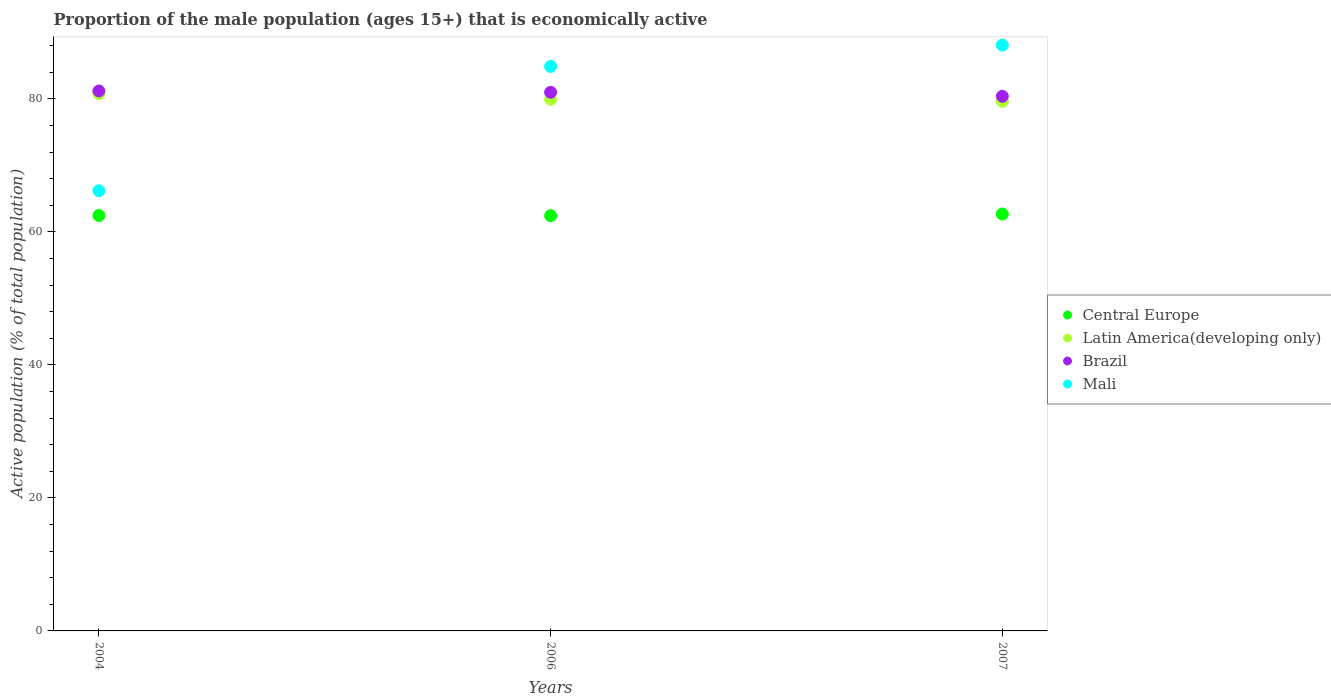What is the proportion of the male population that is economically active in Brazil in 2004?
Provide a short and direct response. 81.2. Across all years, what is the maximum proportion of the male population that is economically active in Latin America(developing only)?
Ensure brevity in your answer.  80.81. Across all years, what is the minimum proportion of the male population that is economically active in Brazil?
Give a very brief answer. 80.4. In which year was the proportion of the male population that is economically active in Mali maximum?
Offer a very short reply. 2007. What is the total proportion of the male population that is economically active in Mali in the graph?
Your answer should be compact. 239.2. What is the difference between the proportion of the male population that is economically active in Central Europe in 2004 and that in 2007?
Offer a terse response. -0.23. What is the difference between the proportion of the male population that is economically active in Brazil in 2006 and the proportion of the male population that is economically active in Central Europe in 2007?
Provide a succinct answer. 18.3. What is the average proportion of the male population that is economically active in Mali per year?
Offer a terse response. 79.73. In the year 2004, what is the difference between the proportion of the male population that is economically active in Latin America(developing only) and proportion of the male population that is economically active in Brazil?
Your answer should be very brief. -0.39. What is the ratio of the proportion of the male population that is economically active in Latin America(developing only) in 2004 to that in 2006?
Offer a terse response. 1.01. What is the difference between the highest and the second highest proportion of the male population that is economically active in Central Europe?
Keep it short and to the point. 0.23. What is the difference between the highest and the lowest proportion of the male population that is economically active in Mali?
Offer a very short reply. 21.9. Is the sum of the proportion of the male population that is economically active in Brazil in 2004 and 2006 greater than the maximum proportion of the male population that is economically active in Mali across all years?
Offer a terse response. Yes. Is it the case that in every year, the sum of the proportion of the male population that is economically active in Brazil and proportion of the male population that is economically active in Latin America(developing only)  is greater than the sum of proportion of the male population that is economically active in Mali and proportion of the male population that is economically active in Central Europe?
Provide a short and direct response. No. How many dotlines are there?
Make the answer very short. 4. How many years are there in the graph?
Your answer should be very brief. 3. What is the difference between two consecutive major ticks on the Y-axis?
Make the answer very short. 20. Are the values on the major ticks of Y-axis written in scientific E-notation?
Your answer should be very brief. No. Where does the legend appear in the graph?
Provide a short and direct response. Center right. What is the title of the graph?
Provide a short and direct response. Proportion of the male population (ages 15+) that is economically active. Does "Cayman Islands" appear as one of the legend labels in the graph?
Offer a terse response. No. What is the label or title of the Y-axis?
Your response must be concise. Active population (% of total population). What is the Active population (% of total population) of Central Europe in 2004?
Keep it short and to the point. 62.47. What is the Active population (% of total population) of Latin America(developing only) in 2004?
Provide a short and direct response. 80.81. What is the Active population (% of total population) of Brazil in 2004?
Your response must be concise. 81.2. What is the Active population (% of total population) in Mali in 2004?
Give a very brief answer. 66.2. What is the Active population (% of total population) of Central Europe in 2006?
Your response must be concise. 62.45. What is the Active population (% of total population) in Latin America(developing only) in 2006?
Give a very brief answer. 79.95. What is the Active population (% of total population) of Brazil in 2006?
Keep it short and to the point. 81. What is the Active population (% of total population) of Mali in 2006?
Offer a very short reply. 84.9. What is the Active population (% of total population) of Central Europe in 2007?
Keep it short and to the point. 62.7. What is the Active population (% of total population) of Latin America(developing only) in 2007?
Your answer should be compact. 79.64. What is the Active population (% of total population) of Brazil in 2007?
Ensure brevity in your answer.  80.4. What is the Active population (% of total population) of Mali in 2007?
Offer a very short reply. 88.1. Across all years, what is the maximum Active population (% of total population) of Central Europe?
Ensure brevity in your answer.  62.7. Across all years, what is the maximum Active population (% of total population) in Latin America(developing only)?
Your answer should be very brief. 80.81. Across all years, what is the maximum Active population (% of total population) in Brazil?
Make the answer very short. 81.2. Across all years, what is the maximum Active population (% of total population) of Mali?
Offer a very short reply. 88.1. Across all years, what is the minimum Active population (% of total population) in Central Europe?
Offer a very short reply. 62.45. Across all years, what is the minimum Active population (% of total population) of Latin America(developing only)?
Make the answer very short. 79.64. Across all years, what is the minimum Active population (% of total population) in Brazil?
Your answer should be very brief. 80.4. Across all years, what is the minimum Active population (% of total population) of Mali?
Offer a very short reply. 66.2. What is the total Active population (% of total population) in Central Europe in the graph?
Offer a very short reply. 187.62. What is the total Active population (% of total population) of Latin America(developing only) in the graph?
Give a very brief answer. 240.39. What is the total Active population (% of total population) in Brazil in the graph?
Offer a terse response. 242.6. What is the total Active population (% of total population) of Mali in the graph?
Keep it short and to the point. 239.2. What is the difference between the Active population (% of total population) of Central Europe in 2004 and that in 2006?
Ensure brevity in your answer.  0.03. What is the difference between the Active population (% of total population) of Latin America(developing only) in 2004 and that in 2006?
Your answer should be compact. 0.86. What is the difference between the Active population (% of total population) of Brazil in 2004 and that in 2006?
Ensure brevity in your answer.  0.2. What is the difference between the Active population (% of total population) in Mali in 2004 and that in 2006?
Make the answer very short. -18.7. What is the difference between the Active population (% of total population) in Central Europe in 2004 and that in 2007?
Provide a short and direct response. -0.23. What is the difference between the Active population (% of total population) of Latin America(developing only) in 2004 and that in 2007?
Your response must be concise. 1.17. What is the difference between the Active population (% of total population) of Brazil in 2004 and that in 2007?
Offer a terse response. 0.8. What is the difference between the Active population (% of total population) of Mali in 2004 and that in 2007?
Offer a terse response. -21.9. What is the difference between the Active population (% of total population) in Central Europe in 2006 and that in 2007?
Your answer should be compact. -0.25. What is the difference between the Active population (% of total population) in Latin America(developing only) in 2006 and that in 2007?
Keep it short and to the point. 0.31. What is the difference between the Active population (% of total population) in Brazil in 2006 and that in 2007?
Your answer should be compact. 0.6. What is the difference between the Active population (% of total population) in Central Europe in 2004 and the Active population (% of total population) in Latin America(developing only) in 2006?
Your answer should be very brief. -17.48. What is the difference between the Active population (% of total population) in Central Europe in 2004 and the Active population (% of total population) in Brazil in 2006?
Your answer should be very brief. -18.53. What is the difference between the Active population (% of total population) of Central Europe in 2004 and the Active population (% of total population) of Mali in 2006?
Make the answer very short. -22.43. What is the difference between the Active population (% of total population) of Latin America(developing only) in 2004 and the Active population (% of total population) of Brazil in 2006?
Your answer should be compact. -0.19. What is the difference between the Active population (% of total population) in Latin America(developing only) in 2004 and the Active population (% of total population) in Mali in 2006?
Offer a terse response. -4.09. What is the difference between the Active population (% of total population) of Central Europe in 2004 and the Active population (% of total population) of Latin America(developing only) in 2007?
Offer a terse response. -17.17. What is the difference between the Active population (% of total population) in Central Europe in 2004 and the Active population (% of total population) in Brazil in 2007?
Your answer should be compact. -17.93. What is the difference between the Active population (% of total population) of Central Europe in 2004 and the Active population (% of total population) of Mali in 2007?
Make the answer very short. -25.63. What is the difference between the Active population (% of total population) of Latin America(developing only) in 2004 and the Active population (% of total population) of Brazil in 2007?
Keep it short and to the point. 0.41. What is the difference between the Active population (% of total population) of Latin America(developing only) in 2004 and the Active population (% of total population) of Mali in 2007?
Provide a succinct answer. -7.29. What is the difference between the Active population (% of total population) in Brazil in 2004 and the Active population (% of total population) in Mali in 2007?
Make the answer very short. -6.9. What is the difference between the Active population (% of total population) in Central Europe in 2006 and the Active population (% of total population) in Latin America(developing only) in 2007?
Keep it short and to the point. -17.19. What is the difference between the Active population (% of total population) in Central Europe in 2006 and the Active population (% of total population) in Brazil in 2007?
Your answer should be very brief. -17.95. What is the difference between the Active population (% of total population) in Central Europe in 2006 and the Active population (% of total population) in Mali in 2007?
Your answer should be very brief. -25.65. What is the difference between the Active population (% of total population) of Latin America(developing only) in 2006 and the Active population (% of total population) of Brazil in 2007?
Your response must be concise. -0.45. What is the difference between the Active population (% of total population) of Latin America(developing only) in 2006 and the Active population (% of total population) of Mali in 2007?
Provide a succinct answer. -8.15. What is the difference between the Active population (% of total population) of Brazil in 2006 and the Active population (% of total population) of Mali in 2007?
Provide a short and direct response. -7.1. What is the average Active population (% of total population) in Central Europe per year?
Keep it short and to the point. 62.54. What is the average Active population (% of total population) of Latin America(developing only) per year?
Offer a terse response. 80.13. What is the average Active population (% of total population) in Brazil per year?
Offer a terse response. 80.87. What is the average Active population (% of total population) of Mali per year?
Offer a terse response. 79.73. In the year 2004, what is the difference between the Active population (% of total population) of Central Europe and Active population (% of total population) of Latin America(developing only)?
Ensure brevity in your answer.  -18.33. In the year 2004, what is the difference between the Active population (% of total population) of Central Europe and Active population (% of total population) of Brazil?
Offer a very short reply. -18.73. In the year 2004, what is the difference between the Active population (% of total population) of Central Europe and Active population (% of total population) of Mali?
Give a very brief answer. -3.73. In the year 2004, what is the difference between the Active population (% of total population) in Latin America(developing only) and Active population (% of total population) in Brazil?
Make the answer very short. -0.39. In the year 2004, what is the difference between the Active population (% of total population) in Latin America(developing only) and Active population (% of total population) in Mali?
Provide a succinct answer. 14.61. In the year 2006, what is the difference between the Active population (% of total population) of Central Europe and Active population (% of total population) of Latin America(developing only)?
Provide a short and direct response. -17.5. In the year 2006, what is the difference between the Active population (% of total population) in Central Europe and Active population (% of total population) in Brazil?
Your answer should be very brief. -18.55. In the year 2006, what is the difference between the Active population (% of total population) in Central Europe and Active population (% of total population) in Mali?
Provide a short and direct response. -22.45. In the year 2006, what is the difference between the Active population (% of total population) of Latin America(developing only) and Active population (% of total population) of Brazil?
Offer a terse response. -1.05. In the year 2006, what is the difference between the Active population (% of total population) of Latin America(developing only) and Active population (% of total population) of Mali?
Make the answer very short. -4.95. In the year 2007, what is the difference between the Active population (% of total population) of Central Europe and Active population (% of total population) of Latin America(developing only)?
Give a very brief answer. -16.94. In the year 2007, what is the difference between the Active population (% of total population) in Central Europe and Active population (% of total population) in Brazil?
Give a very brief answer. -17.7. In the year 2007, what is the difference between the Active population (% of total population) in Central Europe and Active population (% of total population) in Mali?
Offer a terse response. -25.4. In the year 2007, what is the difference between the Active population (% of total population) of Latin America(developing only) and Active population (% of total population) of Brazil?
Keep it short and to the point. -0.76. In the year 2007, what is the difference between the Active population (% of total population) in Latin America(developing only) and Active population (% of total population) in Mali?
Give a very brief answer. -8.46. In the year 2007, what is the difference between the Active population (% of total population) in Brazil and Active population (% of total population) in Mali?
Keep it short and to the point. -7.7. What is the ratio of the Active population (% of total population) in Central Europe in 2004 to that in 2006?
Your response must be concise. 1. What is the ratio of the Active population (% of total population) of Latin America(developing only) in 2004 to that in 2006?
Provide a succinct answer. 1.01. What is the ratio of the Active population (% of total population) in Brazil in 2004 to that in 2006?
Your answer should be compact. 1. What is the ratio of the Active population (% of total population) of Mali in 2004 to that in 2006?
Your answer should be very brief. 0.78. What is the ratio of the Active population (% of total population) in Central Europe in 2004 to that in 2007?
Keep it short and to the point. 1. What is the ratio of the Active population (% of total population) of Latin America(developing only) in 2004 to that in 2007?
Provide a short and direct response. 1.01. What is the ratio of the Active population (% of total population) in Brazil in 2004 to that in 2007?
Ensure brevity in your answer.  1.01. What is the ratio of the Active population (% of total population) of Mali in 2004 to that in 2007?
Give a very brief answer. 0.75. What is the ratio of the Active population (% of total population) of Latin America(developing only) in 2006 to that in 2007?
Provide a succinct answer. 1. What is the ratio of the Active population (% of total population) of Brazil in 2006 to that in 2007?
Your answer should be compact. 1.01. What is the ratio of the Active population (% of total population) of Mali in 2006 to that in 2007?
Provide a succinct answer. 0.96. What is the difference between the highest and the second highest Active population (% of total population) of Central Europe?
Your response must be concise. 0.23. What is the difference between the highest and the second highest Active population (% of total population) of Latin America(developing only)?
Your answer should be compact. 0.86. What is the difference between the highest and the second highest Active population (% of total population) in Brazil?
Your response must be concise. 0.2. What is the difference between the highest and the second highest Active population (% of total population) in Mali?
Your response must be concise. 3.2. What is the difference between the highest and the lowest Active population (% of total population) in Central Europe?
Give a very brief answer. 0.25. What is the difference between the highest and the lowest Active population (% of total population) in Latin America(developing only)?
Offer a terse response. 1.17. What is the difference between the highest and the lowest Active population (% of total population) in Brazil?
Your response must be concise. 0.8. What is the difference between the highest and the lowest Active population (% of total population) in Mali?
Provide a short and direct response. 21.9. 